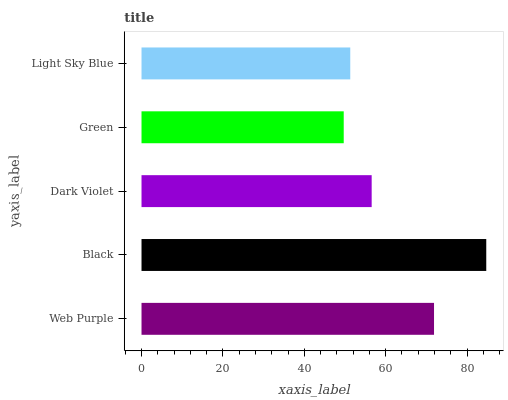Is Green the minimum?
Answer yes or no. Yes. Is Black the maximum?
Answer yes or no. Yes. Is Dark Violet the minimum?
Answer yes or no. No. Is Dark Violet the maximum?
Answer yes or no. No. Is Black greater than Dark Violet?
Answer yes or no. Yes. Is Dark Violet less than Black?
Answer yes or no. Yes. Is Dark Violet greater than Black?
Answer yes or no. No. Is Black less than Dark Violet?
Answer yes or no. No. Is Dark Violet the high median?
Answer yes or no. Yes. Is Dark Violet the low median?
Answer yes or no. Yes. Is Green the high median?
Answer yes or no. No. Is Light Sky Blue the low median?
Answer yes or no. No. 